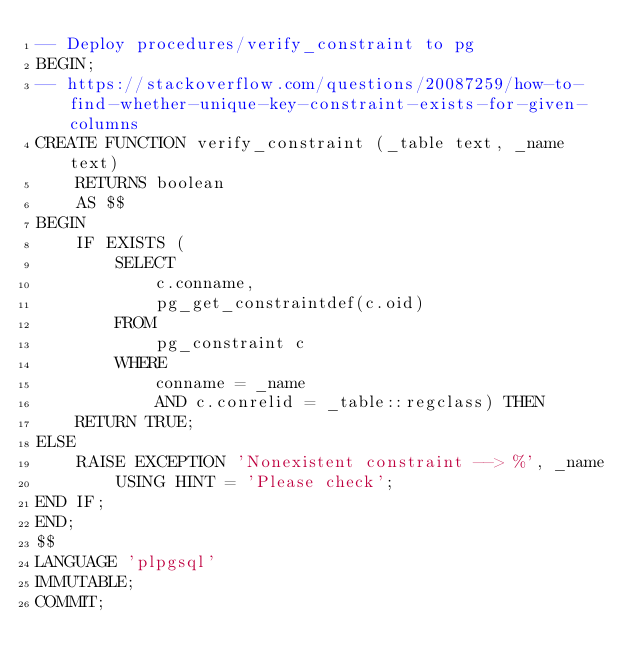<code> <loc_0><loc_0><loc_500><loc_500><_SQL_>-- Deploy procedures/verify_constraint to pg
BEGIN;
-- https://stackoverflow.com/questions/20087259/how-to-find-whether-unique-key-constraint-exists-for-given-columns
CREATE FUNCTION verify_constraint (_table text, _name text)
    RETURNS boolean
    AS $$
BEGIN
    IF EXISTS (
        SELECT
            c.conname,
            pg_get_constraintdef(c.oid)
        FROM
            pg_constraint c
        WHERE
            conname = _name
            AND c.conrelid = _table::regclass) THEN
    RETURN TRUE;
ELSE
    RAISE EXCEPTION 'Nonexistent constraint --> %', _name
        USING HINT = 'Please check';
END IF;
END;
$$
LANGUAGE 'plpgsql'
IMMUTABLE;
COMMIT;

</code> 